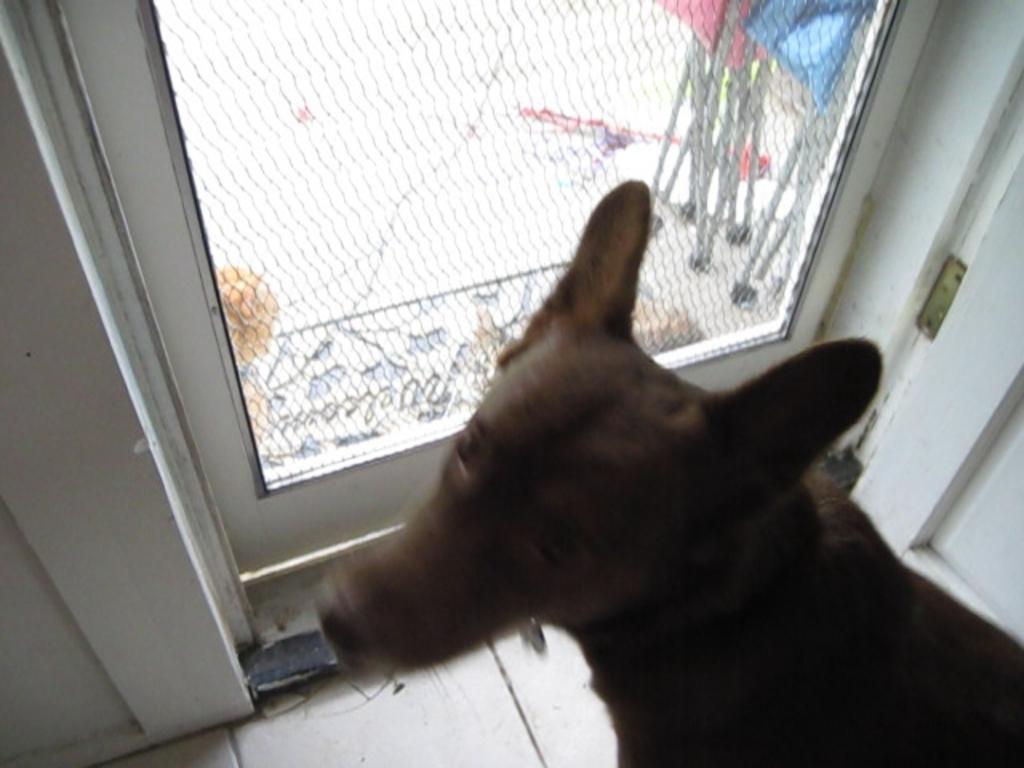Please provide a concise description of this image. In this image I can see an animal which is in brown color. To the side I can see the glass door. Through the glass I can see some objects. 